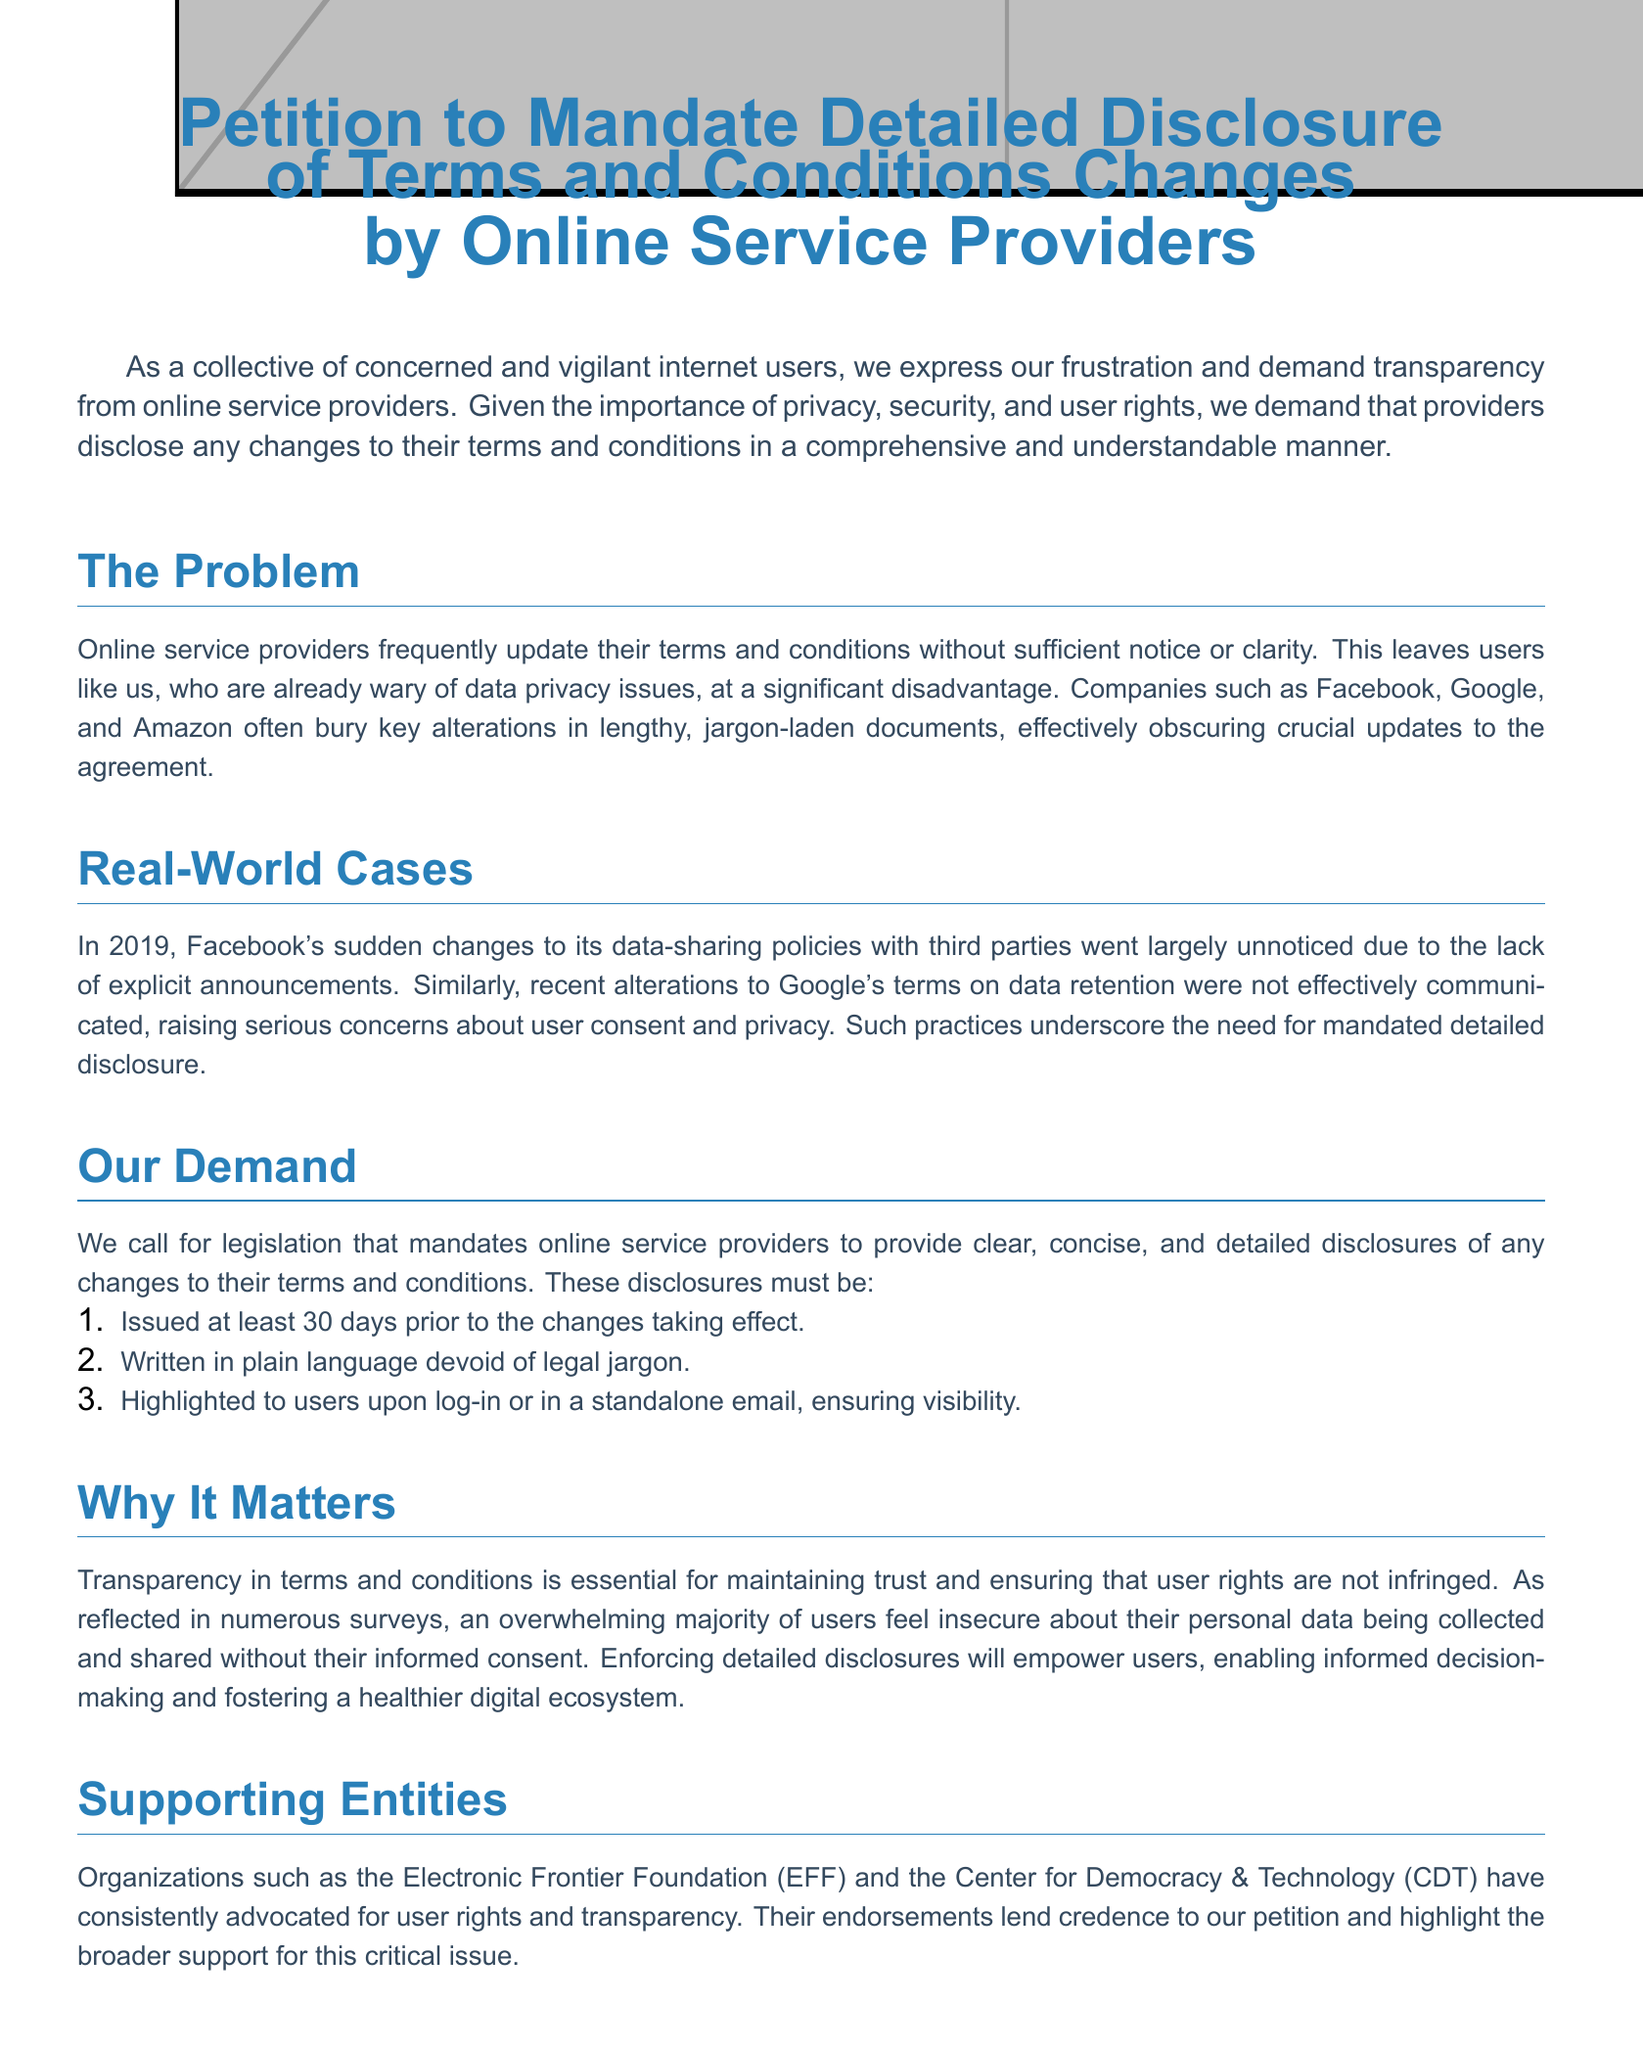What is the title of the petition? The title of the petition is prominently displayed at the top of the document.
Answer: Petition to Mandate Detailed Disclosure of Terms and Conditions Changes by Online Service Providers Who are some organizations that support this petition? The document lists specific organizations that endorse the petition.
Answer: Electronic Frontier Foundation (EFF) and Center for Democracy & Technology (CDT) How many days prior to changes must disclosures be issued? The petition specifies a time frame for when disclosures should be communicated to users.
Answer: 30 days What language should the disclosures be written in? The document indicates the desired language style for the disclosures to ensure user understanding.
Answer: Plain language What is the main concern expressed in the petition? The petition conveys a primary concern regarding user rights and privacy issues related to online services.
Answer: Transparency What is the purpose of the petition? The document outlines the fundamental aim behind initiating the petition for better practices in terms and conditions disclosures.
Answer: To demand transparency from online service providers What should be highlighted to users upon log-in? The petition specifies a method of ensuring that users are aware of the changes to terms and conditions.
Answer: Changes to terms and conditions What year did Facebook change its data-sharing policies? The document provides a specific year referencing notable cases related to terms and conditions.
Answer: 2019 